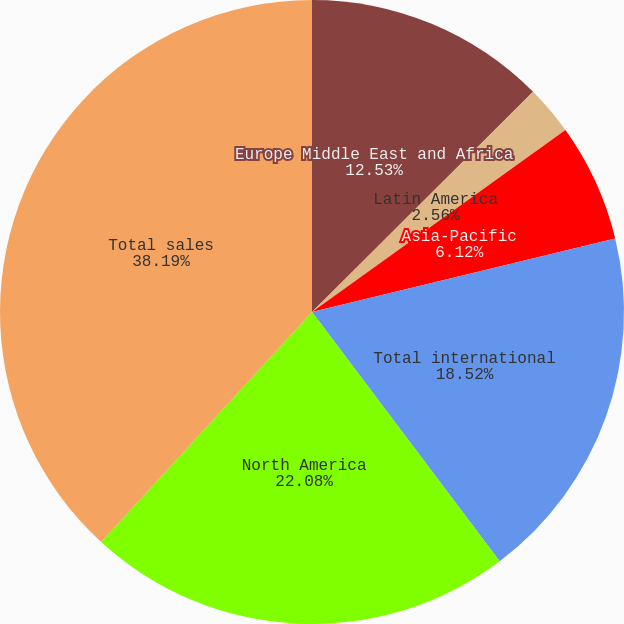Convert chart. <chart><loc_0><loc_0><loc_500><loc_500><pie_chart><fcel>Europe Middle East and Africa<fcel>Latin America<fcel>Asia-Pacific<fcel>Total international<fcel>North America<fcel>Total sales<nl><fcel>12.53%<fcel>2.56%<fcel>6.12%<fcel>18.52%<fcel>22.08%<fcel>38.19%<nl></chart> 